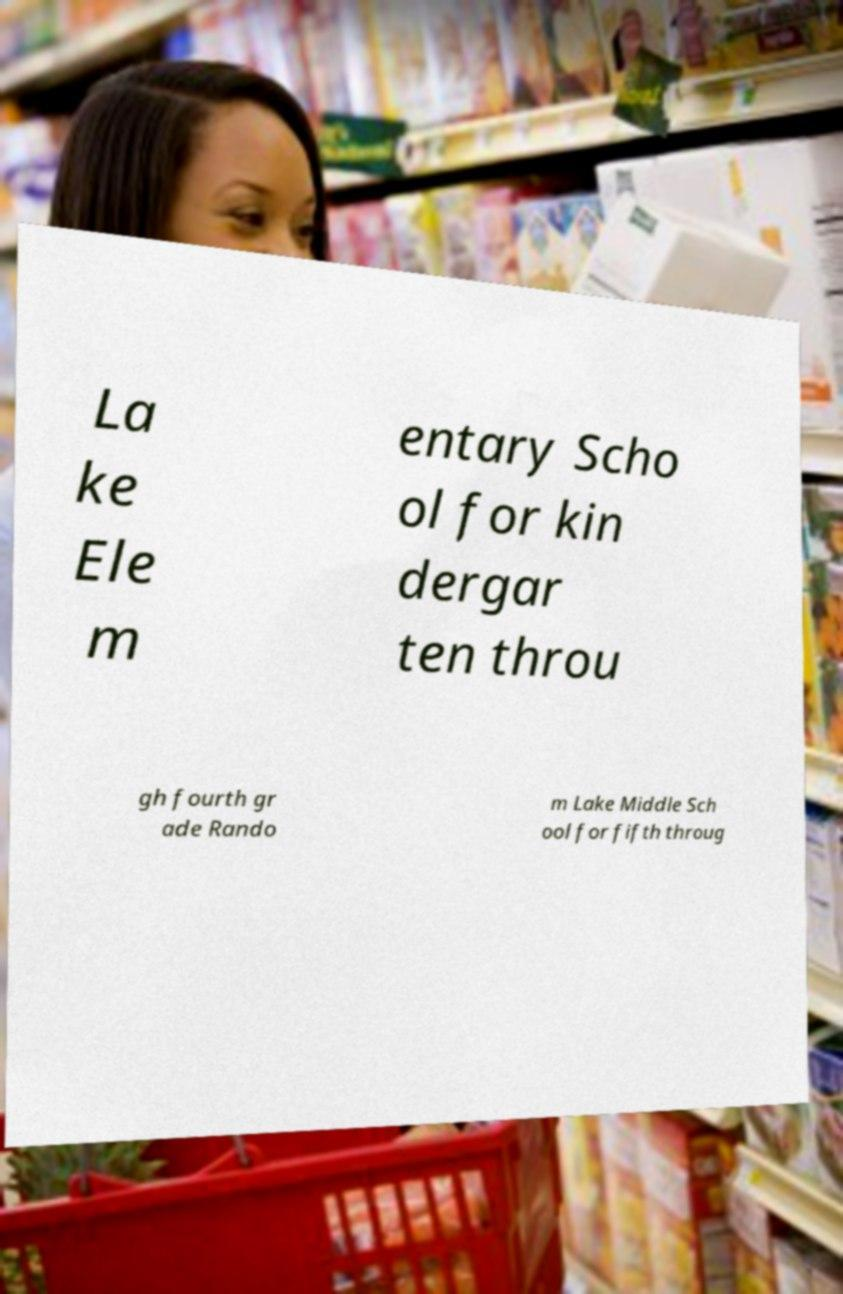Could you extract and type out the text from this image? La ke Ele m entary Scho ol for kin dergar ten throu gh fourth gr ade Rando m Lake Middle Sch ool for fifth throug 